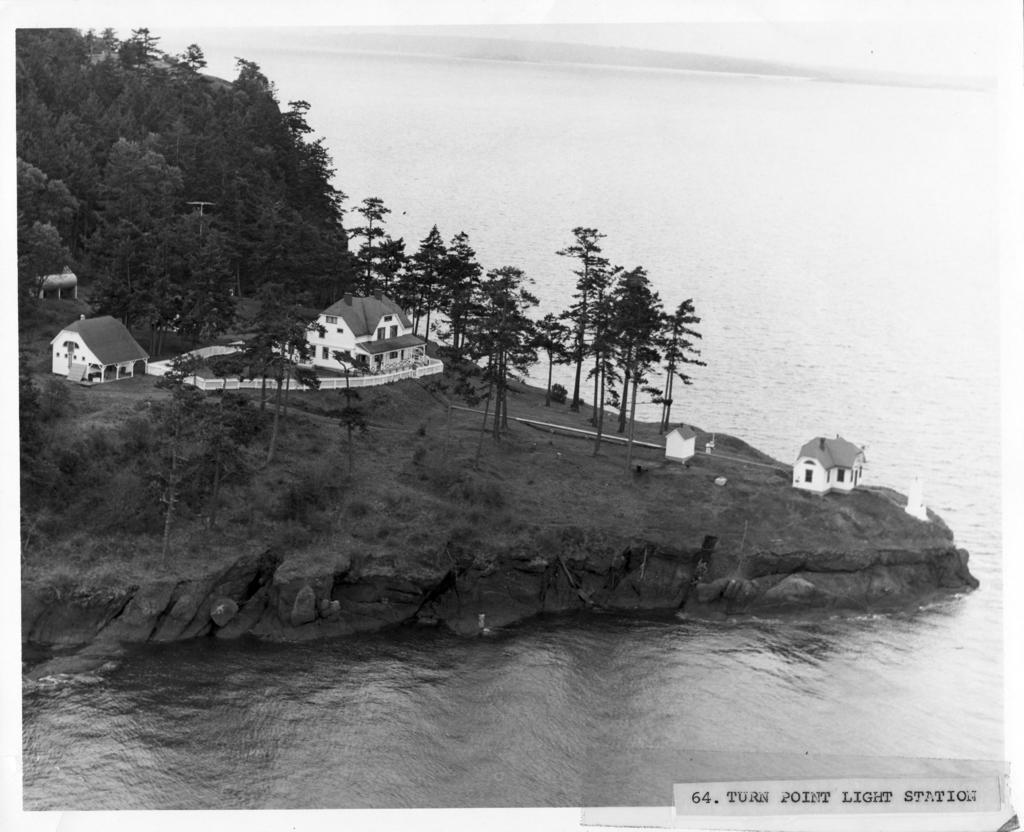What is covering the area in the image? Water is covering a place in the image. What type of vegetation can be seen on the ground in the image? Grass is visible on the ground in the image. What other types of vegetation are present in the image? Plants and trees are visible in the image. Are there any structures visible in the image? Yes, houses are present in the image. What is the cause of the arm's injury in the image? There is no arm or injury present in the image. 